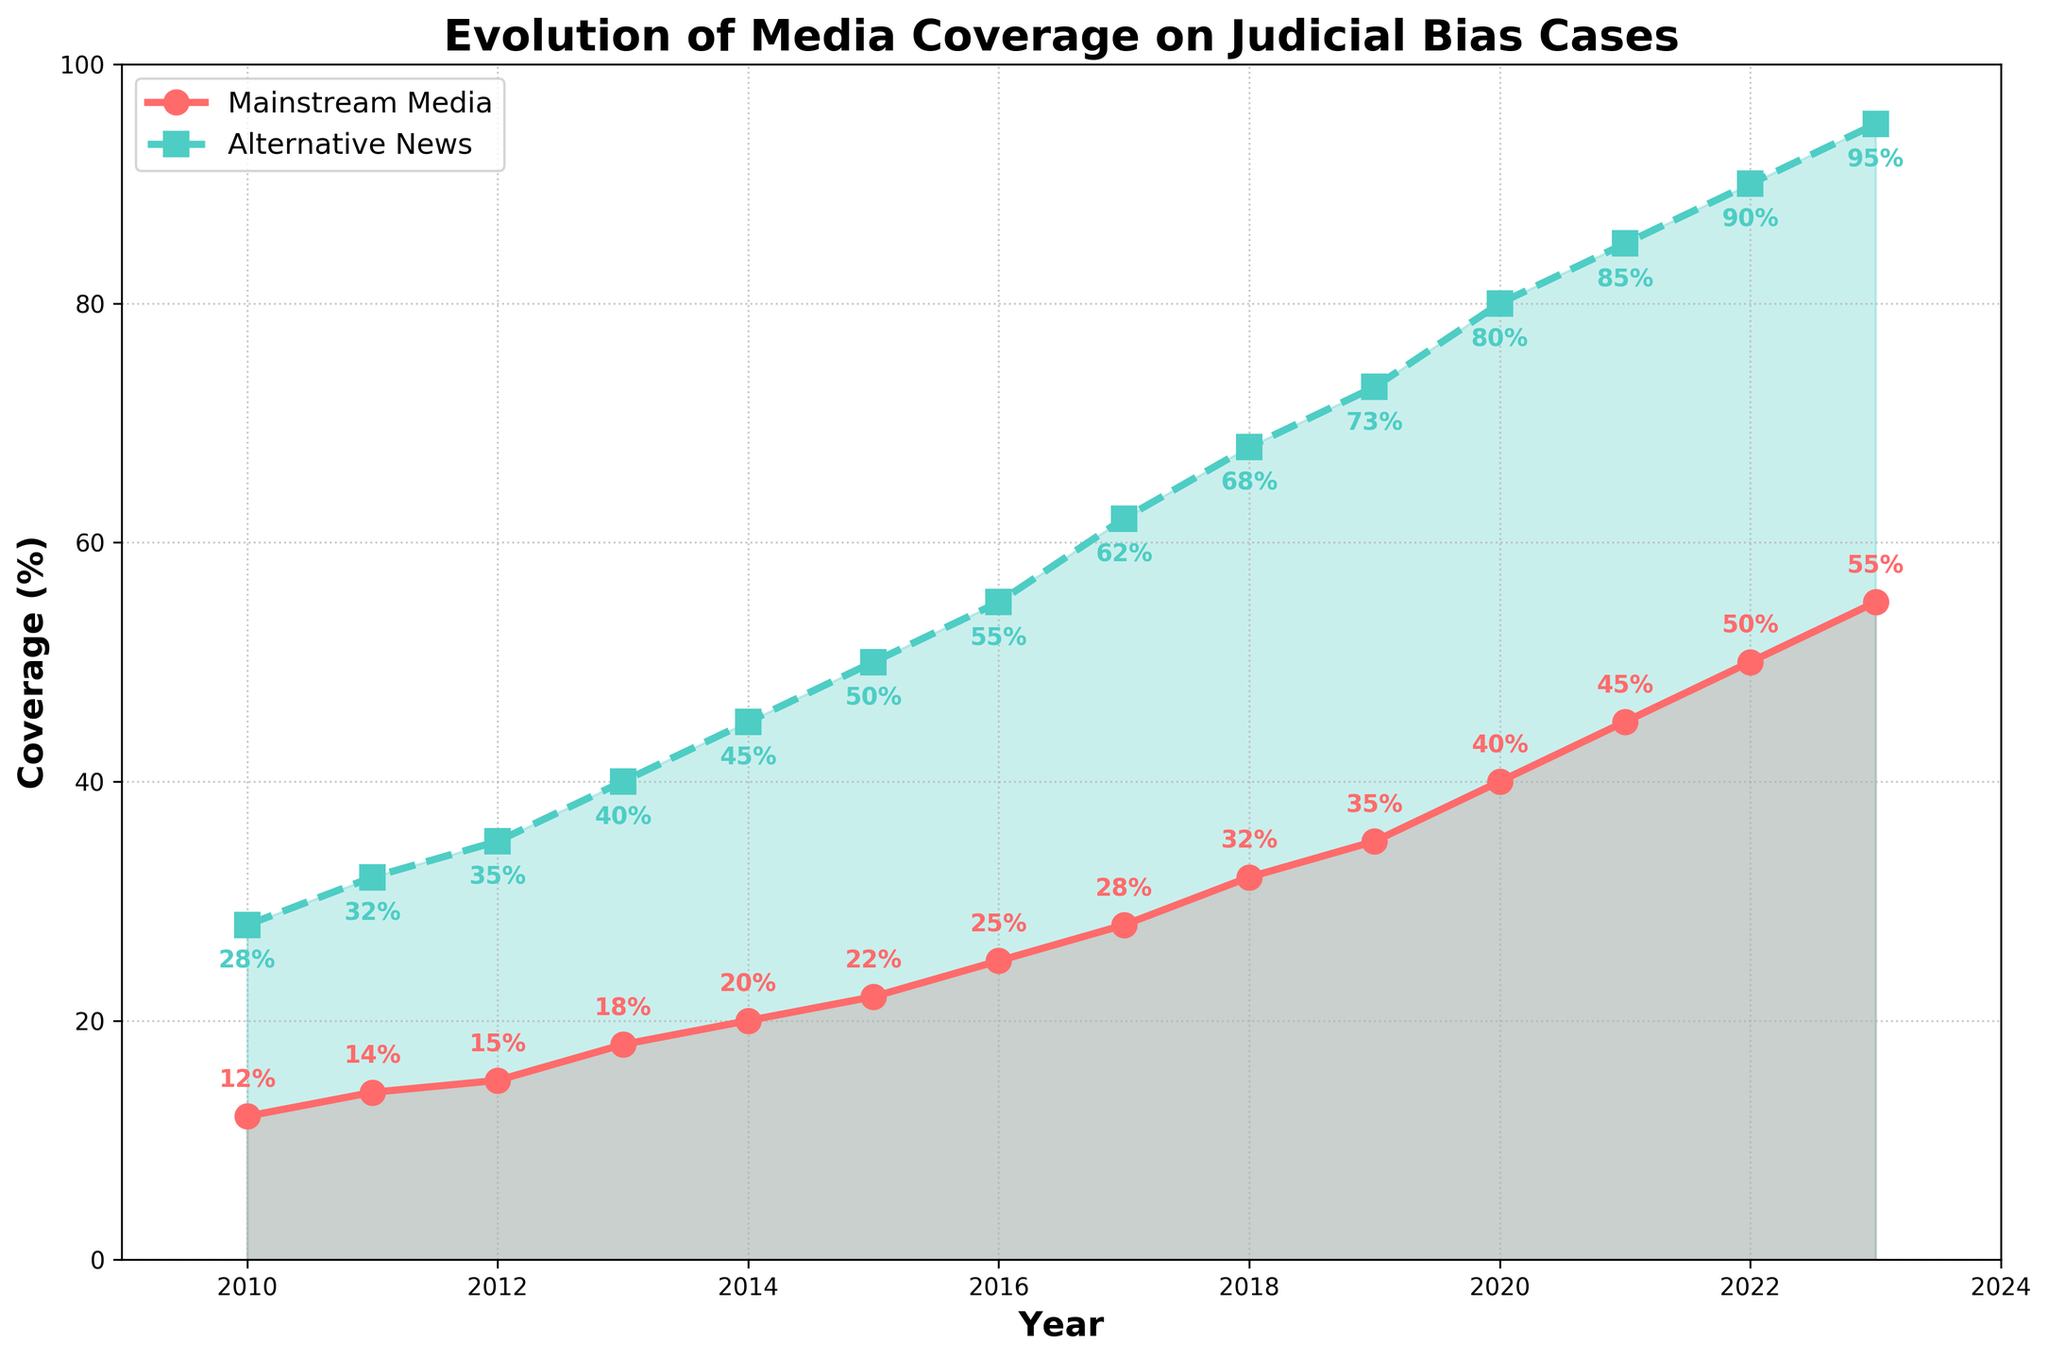What can you say about the trend of mainstream media coverage from 2010 to 2023? The trend of mainstream media coverage shows a steady increase from 12% in 2010 to 55% in 2023. Each year, there's a gradual rise, with no decreases observed.
Answer: Steady increase How does the alternative news coverage in 2016 compare to that in 2023? In 2016, the alternative news coverage was 55%, while in 2023, it increased to 95%. This indicates a significant rise of 40 percentage points over these seven years.
Answer: Increased by 40 percentage points In which year did the alternative news coverage first exceed 50%? By looking at the visual representation, alternative news coverage first exceeded 50% in 2015.
Answer: 2015 What's the difference between mainstream and alternative news coverage in the year 2022? In 2022, mainstream media coverage was 50%, and alternative news coverage was 90%. The difference between them is 90% - 50% = 40%.
Answer: 40% What can you infer about the relative coverage of mainstream and alternative news sources in 2020? In 2020, mainstream media coverage was 40% and alternative news coverage was 80%. Alternative news covered 40 percentage points more than mainstream media.
Answer: Alternative news covered 40 percentage points more Comparing mainstream media coverage between 2011 and 2017, by what percentage did it increase? Mainstream media coverage in 2011 was 14%, and in 2017 it was 28%. The increase is 28% - 14% = 14 percentage points.
Answer: 14 percentage points Which year experienced the highest annual increase in mainstream media coverage? Between 2019 and 2020, mainstream media coverage increased from 35% to 40%, an increase of 5 percentage points, which is the highest annual increase observed.
Answer: 2019 to 2020 By the end of the measured period, what approximation can you make about the proportion of coverage dedicated to judicial bias by alternative news compared to mainstream media? By 2023, alternative news coverage on judicial bias is approximately 95%, while mainstream media is at 55%. Alternative news dedicates roughly 1.73 times more coverage to this issue.
Answer: 1.73 times more From 2018 to 2023, what is the cumulative increase in mainstream media coverage? Mainstream media coverage in 2018 was 32%, and in 2023 it was 55%. The cumulative increase over these five years is 55% - 32% = 23 percentage points.
Answer: 23 percentage points What is the average coverage of judicial bias cases by alternative news sources from 2010 to 2023? Sum all the annual alternative news coverage percentages from 2010 to 2023: 28 + 32 + 35 + 40 + 45 + 50 + 55 + 62 + 68 + 73 + 80 + 85 + 90 + 95 = 838. Then divide by the number of years (14): 838/14 ≈ 59.9%.
Answer: 59.9% 